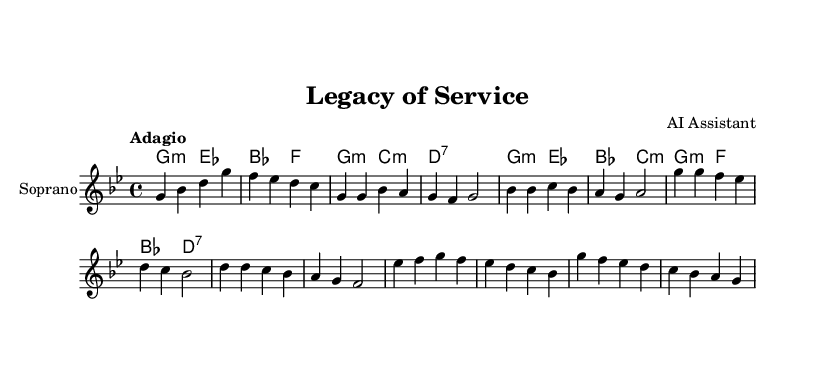What is the key signature of this music? The key signature is G minor, which contains two flats (B♭ and E♭), indicated by the symbol at the beginning of the staff.
Answer: G minor What is the time signature of this piece? The time signature is 4/4, as indicated by the fraction at the beginning of the score, meaning there are four beats per measure and the quarter note gets one beat.
Answer: 4/4 What is the tempo marking of the piece? The tempo marking is "Adagio," which indicates that the music should be played slowly and leisurely, typically at a pace of 66-76 beats per minute.
Answer: Adagio How many measures are there in the introduction? The introduction consists of two measures, which can be counted by looking at the measures and their corresponding bar lines at the beginning of the music.
Answer: 2 What is the main theme of the music based on its lyrics? The main theme revolves around family legacy and the commitment to serve and protect, as expressed in the lyrics describing heritage and strength in the face of challenges.
Answer: Family legacy What emotional tone does the bridge convey compared to the verse? The bridge conveys a tone of hope and remembrance, contrasting with the verse's emphasis on duty, by focusing on inner strength and identity during difficult times.
Answer: Hope What type of musical structure is present in this opera? The structure includes an introduction, verses, a chorus, and a bridge, typical for operatic arias to develop emotional depth and storytelling through music.
Answer: Verse-Chorus-Bridge 